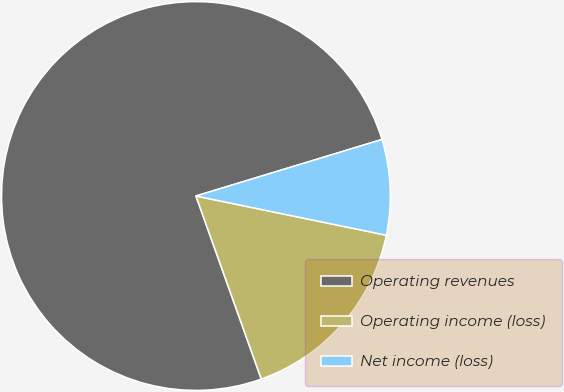Convert chart to OTSL. <chart><loc_0><loc_0><loc_500><loc_500><pie_chart><fcel>Operating revenues<fcel>Operating income (loss)<fcel>Net income (loss)<nl><fcel>75.76%<fcel>16.31%<fcel>7.93%<nl></chart> 